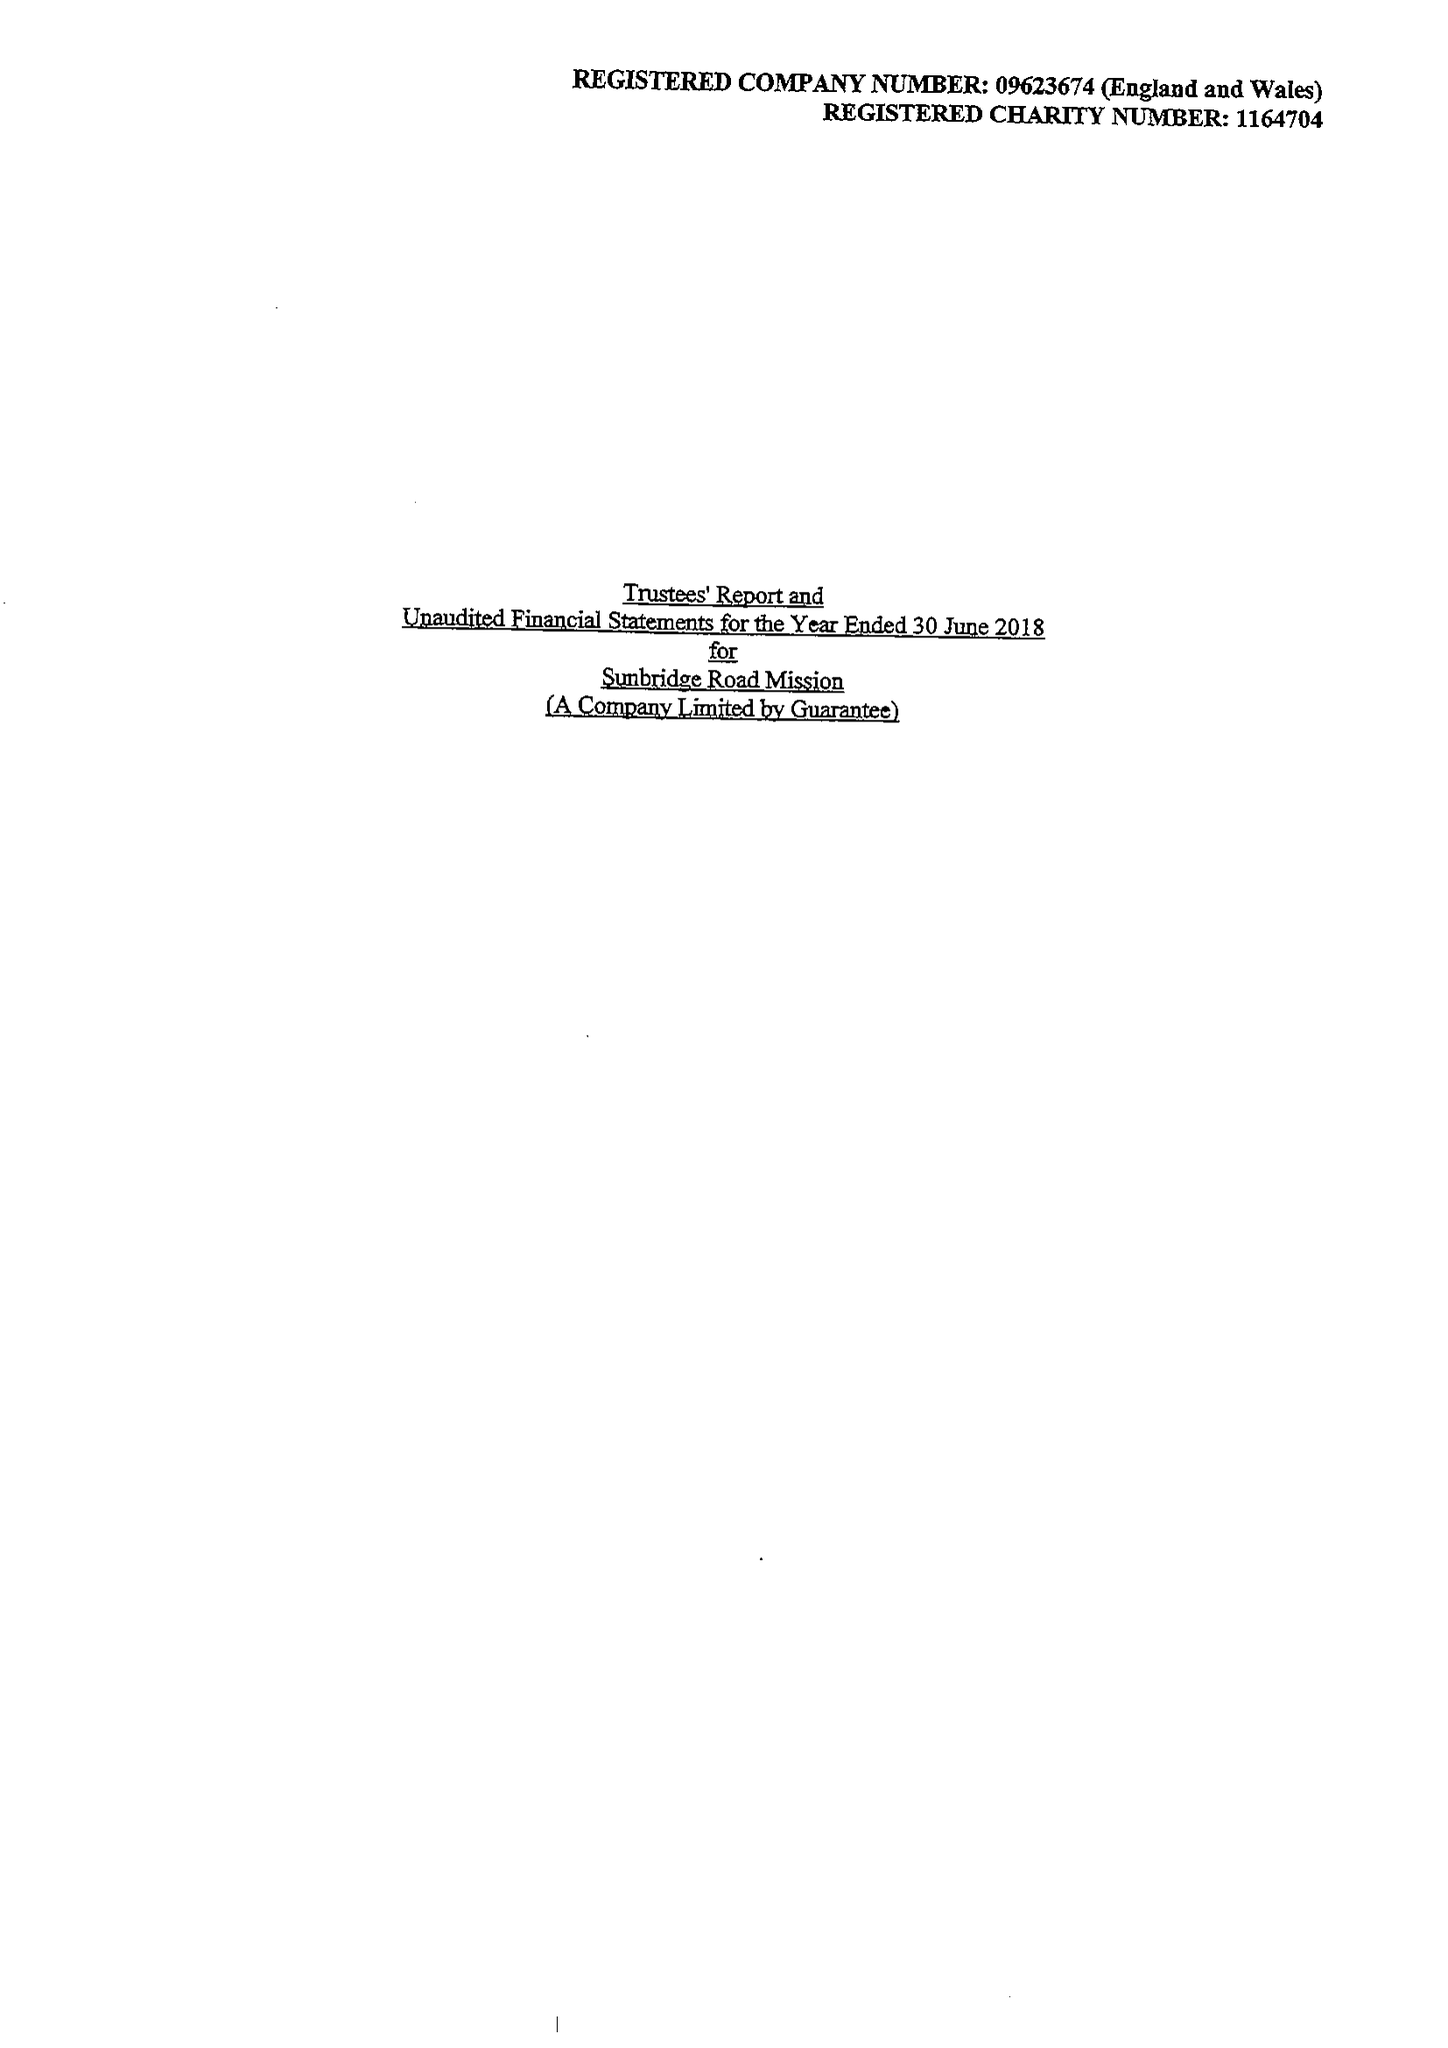What is the value for the charity_name?
Answer the question using a single word or phrase. Sunbridge Road Mission 